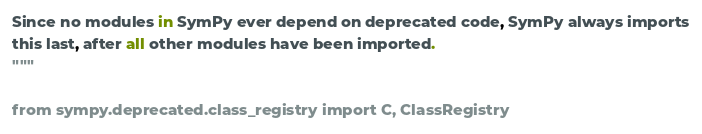<code> <loc_0><loc_0><loc_500><loc_500><_Python_>Since no modules in SymPy ever depend on deprecated code, SymPy always imports
this last, after all other modules have been imported.
"""

from sympy.deprecated.class_registry import C, ClassRegistry
</code> 